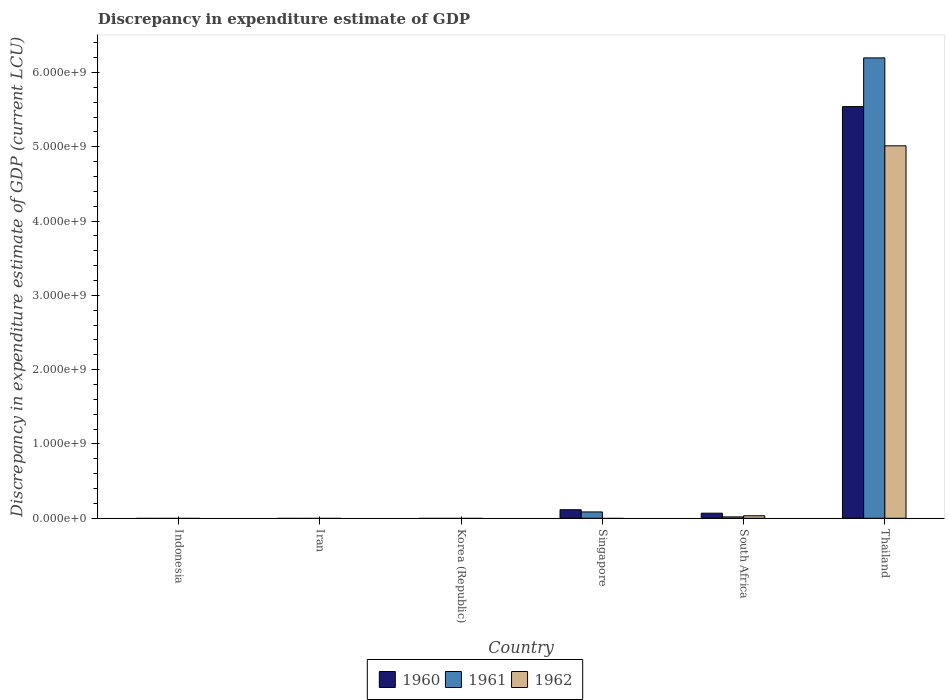How many bars are there on the 4th tick from the right?
Provide a short and direct response. 0. What is the label of the 5th group of bars from the left?
Offer a very short reply. South Africa. In how many cases, is the number of bars for a given country not equal to the number of legend labels?
Provide a succinct answer. 4. What is the discrepancy in expenditure estimate of GDP in 1961 in South Africa?
Make the answer very short. 1.84e+07. Across all countries, what is the maximum discrepancy in expenditure estimate of GDP in 1962?
Your response must be concise. 5.01e+09. Across all countries, what is the minimum discrepancy in expenditure estimate of GDP in 1962?
Make the answer very short. 0. In which country was the discrepancy in expenditure estimate of GDP in 1960 maximum?
Provide a succinct answer. Thailand. What is the total discrepancy in expenditure estimate of GDP in 1961 in the graph?
Provide a short and direct response. 6.30e+09. What is the difference between the discrepancy in expenditure estimate of GDP in 1961 in Singapore and that in South Africa?
Keep it short and to the point. 6.69e+07. What is the difference between the discrepancy in expenditure estimate of GDP in 1962 in Thailand and the discrepancy in expenditure estimate of GDP in 1961 in Indonesia?
Your response must be concise. 5.01e+09. What is the average discrepancy in expenditure estimate of GDP in 1961 per country?
Offer a terse response. 1.05e+09. What is the difference between the discrepancy in expenditure estimate of GDP of/in 1962 and discrepancy in expenditure estimate of GDP of/in 1960 in South Africa?
Your answer should be very brief. -3.43e+07. In how many countries, is the discrepancy in expenditure estimate of GDP in 1961 greater than 600000000 LCU?
Provide a short and direct response. 1. What is the ratio of the discrepancy in expenditure estimate of GDP in 1961 in Singapore to that in Thailand?
Ensure brevity in your answer.  0.01. What is the difference between the highest and the second highest discrepancy in expenditure estimate of GDP in 1960?
Your answer should be very brief. 4.66e+07. What is the difference between the highest and the lowest discrepancy in expenditure estimate of GDP in 1962?
Provide a short and direct response. 5.01e+09. Is the sum of the discrepancy in expenditure estimate of GDP in 1960 in South Africa and Thailand greater than the maximum discrepancy in expenditure estimate of GDP in 1962 across all countries?
Ensure brevity in your answer.  Yes. Is it the case that in every country, the sum of the discrepancy in expenditure estimate of GDP in 1962 and discrepancy in expenditure estimate of GDP in 1960 is greater than the discrepancy in expenditure estimate of GDP in 1961?
Provide a short and direct response. No. How many bars are there?
Your response must be concise. 8. How many countries are there in the graph?
Provide a short and direct response. 6. What is the difference between two consecutive major ticks on the Y-axis?
Your response must be concise. 1.00e+09. Where does the legend appear in the graph?
Provide a short and direct response. Bottom center. How are the legend labels stacked?
Make the answer very short. Horizontal. What is the title of the graph?
Make the answer very short. Discrepancy in expenditure estimate of GDP. Does "2006" appear as one of the legend labels in the graph?
Make the answer very short. No. What is the label or title of the Y-axis?
Ensure brevity in your answer.  Discrepancy in expenditure estimate of GDP (current LCU). What is the Discrepancy in expenditure estimate of GDP (current LCU) in 1960 in Indonesia?
Offer a terse response. 0. What is the Discrepancy in expenditure estimate of GDP (current LCU) of 1961 in Indonesia?
Your answer should be compact. 0. What is the Discrepancy in expenditure estimate of GDP (current LCU) of 1960 in Iran?
Give a very brief answer. 0. What is the Discrepancy in expenditure estimate of GDP (current LCU) in 1961 in Iran?
Give a very brief answer. 0. What is the Discrepancy in expenditure estimate of GDP (current LCU) in 1962 in Iran?
Your answer should be very brief. 0. What is the Discrepancy in expenditure estimate of GDP (current LCU) of 1961 in Korea (Republic)?
Provide a short and direct response. 0. What is the Discrepancy in expenditure estimate of GDP (current LCU) in 1960 in Singapore?
Your answer should be very brief. 1.15e+08. What is the Discrepancy in expenditure estimate of GDP (current LCU) in 1961 in Singapore?
Keep it short and to the point. 8.53e+07. What is the Discrepancy in expenditure estimate of GDP (current LCU) of 1960 in South Africa?
Keep it short and to the point. 6.83e+07. What is the Discrepancy in expenditure estimate of GDP (current LCU) in 1961 in South Africa?
Keep it short and to the point. 1.84e+07. What is the Discrepancy in expenditure estimate of GDP (current LCU) in 1962 in South Africa?
Offer a terse response. 3.40e+07. What is the Discrepancy in expenditure estimate of GDP (current LCU) in 1960 in Thailand?
Make the answer very short. 5.54e+09. What is the Discrepancy in expenditure estimate of GDP (current LCU) of 1961 in Thailand?
Your response must be concise. 6.20e+09. What is the Discrepancy in expenditure estimate of GDP (current LCU) in 1962 in Thailand?
Ensure brevity in your answer.  5.01e+09. Across all countries, what is the maximum Discrepancy in expenditure estimate of GDP (current LCU) of 1960?
Your response must be concise. 5.54e+09. Across all countries, what is the maximum Discrepancy in expenditure estimate of GDP (current LCU) of 1961?
Offer a terse response. 6.20e+09. Across all countries, what is the maximum Discrepancy in expenditure estimate of GDP (current LCU) of 1962?
Your answer should be compact. 5.01e+09. Across all countries, what is the minimum Discrepancy in expenditure estimate of GDP (current LCU) of 1960?
Offer a terse response. 0. Across all countries, what is the minimum Discrepancy in expenditure estimate of GDP (current LCU) of 1962?
Make the answer very short. 0. What is the total Discrepancy in expenditure estimate of GDP (current LCU) of 1960 in the graph?
Ensure brevity in your answer.  5.72e+09. What is the total Discrepancy in expenditure estimate of GDP (current LCU) in 1961 in the graph?
Ensure brevity in your answer.  6.30e+09. What is the total Discrepancy in expenditure estimate of GDP (current LCU) of 1962 in the graph?
Offer a terse response. 5.05e+09. What is the difference between the Discrepancy in expenditure estimate of GDP (current LCU) of 1960 in Singapore and that in South Africa?
Your response must be concise. 4.66e+07. What is the difference between the Discrepancy in expenditure estimate of GDP (current LCU) in 1961 in Singapore and that in South Africa?
Provide a short and direct response. 6.69e+07. What is the difference between the Discrepancy in expenditure estimate of GDP (current LCU) in 1960 in Singapore and that in Thailand?
Give a very brief answer. -5.43e+09. What is the difference between the Discrepancy in expenditure estimate of GDP (current LCU) of 1961 in Singapore and that in Thailand?
Make the answer very short. -6.11e+09. What is the difference between the Discrepancy in expenditure estimate of GDP (current LCU) in 1960 in South Africa and that in Thailand?
Your answer should be compact. -5.47e+09. What is the difference between the Discrepancy in expenditure estimate of GDP (current LCU) of 1961 in South Africa and that in Thailand?
Your answer should be very brief. -6.18e+09. What is the difference between the Discrepancy in expenditure estimate of GDP (current LCU) of 1962 in South Africa and that in Thailand?
Give a very brief answer. -4.98e+09. What is the difference between the Discrepancy in expenditure estimate of GDP (current LCU) in 1960 in Singapore and the Discrepancy in expenditure estimate of GDP (current LCU) in 1961 in South Africa?
Keep it short and to the point. 9.65e+07. What is the difference between the Discrepancy in expenditure estimate of GDP (current LCU) in 1960 in Singapore and the Discrepancy in expenditure estimate of GDP (current LCU) in 1962 in South Africa?
Provide a short and direct response. 8.09e+07. What is the difference between the Discrepancy in expenditure estimate of GDP (current LCU) in 1961 in Singapore and the Discrepancy in expenditure estimate of GDP (current LCU) in 1962 in South Africa?
Ensure brevity in your answer.  5.13e+07. What is the difference between the Discrepancy in expenditure estimate of GDP (current LCU) of 1960 in Singapore and the Discrepancy in expenditure estimate of GDP (current LCU) of 1961 in Thailand?
Your response must be concise. -6.08e+09. What is the difference between the Discrepancy in expenditure estimate of GDP (current LCU) in 1960 in Singapore and the Discrepancy in expenditure estimate of GDP (current LCU) in 1962 in Thailand?
Give a very brief answer. -4.90e+09. What is the difference between the Discrepancy in expenditure estimate of GDP (current LCU) in 1961 in Singapore and the Discrepancy in expenditure estimate of GDP (current LCU) in 1962 in Thailand?
Your answer should be compact. -4.93e+09. What is the difference between the Discrepancy in expenditure estimate of GDP (current LCU) of 1960 in South Africa and the Discrepancy in expenditure estimate of GDP (current LCU) of 1961 in Thailand?
Make the answer very short. -6.13e+09. What is the difference between the Discrepancy in expenditure estimate of GDP (current LCU) in 1960 in South Africa and the Discrepancy in expenditure estimate of GDP (current LCU) in 1962 in Thailand?
Keep it short and to the point. -4.95e+09. What is the difference between the Discrepancy in expenditure estimate of GDP (current LCU) of 1961 in South Africa and the Discrepancy in expenditure estimate of GDP (current LCU) of 1962 in Thailand?
Your answer should be compact. -5.00e+09. What is the average Discrepancy in expenditure estimate of GDP (current LCU) in 1960 per country?
Your answer should be very brief. 9.54e+08. What is the average Discrepancy in expenditure estimate of GDP (current LCU) in 1961 per country?
Your answer should be compact. 1.05e+09. What is the average Discrepancy in expenditure estimate of GDP (current LCU) in 1962 per country?
Your answer should be compact. 8.41e+08. What is the difference between the Discrepancy in expenditure estimate of GDP (current LCU) of 1960 and Discrepancy in expenditure estimate of GDP (current LCU) of 1961 in Singapore?
Give a very brief answer. 2.96e+07. What is the difference between the Discrepancy in expenditure estimate of GDP (current LCU) of 1960 and Discrepancy in expenditure estimate of GDP (current LCU) of 1961 in South Africa?
Provide a succinct answer. 4.99e+07. What is the difference between the Discrepancy in expenditure estimate of GDP (current LCU) in 1960 and Discrepancy in expenditure estimate of GDP (current LCU) in 1962 in South Africa?
Keep it short and to the point. 3.43e+07. What is the difference between the Discrepancy in expenditure estimate of GDP (current LCU) in 1961 and Discrepancy in expenditure estimate of GDP (current LCU) in 1962 in South Africa?
Keep it short and to the point. -1.56e+07. What is the difference between the Discrepancy in expenditure estimate of GDP (current LCU) in 1960 and Discrepancy in expenditure estimate of GDP (current LCU) in 1961 in Thailand?
Your response must be concise. -6.56e+08. What is the difference between the Discrepancy in expenditure estimate of GDP (current LCU) of 1960 and Discrepancy in expenditure estimate of GDP (current LCU) of 1962 in Thailand?
Keep it short and to the point. 5.28e+08. What is the difference between the Discrepancy in expenditure estimate of GDP (current LCU) in 1961 and Discrepancy in expenditure estimate of GDP (current LCU) in 1962 in Thailand?
Offer a very short reply. 1.18e+09. What is the ratio of the Discrepancy in expenditure estimate of GDP (current LCU) of 1960 in Singapore to that in South Africa?
Keep it short and to the point. 1.68. What is the ratio of the Discrepancy in expenditure estimate of GDP (current LCU) in 1961 in Singapore to that in South Africa?
Offer a very short reply. 4.64. What is the ratio of the Discrepancy in expenditure estimate of GDP (current LCU) in 1960 in Singapore to that in Thailand?
Provide a short and direct response. 0.02. What is the ratio of the Discrepancy in expenditure estimate of GDP (current LCU) of 1961 in Singapore to that in Thailand?
Ensure brevity in your answer.  0.01. What is the ratio of the Discrepancy in expenditure estimate of GDP (current LCU) of 1960 in South Africa to that in Thailand?
Provide a short and direct response. 0.01. What is the ratio of the Discrepancy in expenditure estimate of GDP (current LCU) in 1961 in South Africa to that in Thailand?
Your answer should be very brief. 0. What is the ratio of the Discrepancy in expenditure estimate of GDP (current LCU) of 1962 in South Africa to that in Thailand?
Provide a short and direct response. 0.01. What is the difference between the highest and the second highest Discrepancy in expenditure estimate of GDP (current LCU) of 1960?
Provide a succinct answer. 5.43e+09. What is the difference between the highest and the second highest Discrepancy in expenditure estimate of GDP (current LCU) of 1961?
Give a very brief answer. 6.11e+09. What is the difference between the highest and the lowest Discrepancy in expenditure estimate of GDP (current LCU) in 1960?
Provide a short and direct response. 5.54e+09. What is the difference between the highest and the lowest Discrepancy in expenditure estimate of GDP (current LCU) in 1961?
Offer a very short reply. 6.20e+09. What is the difference between the highest and the lowest Discrepancy in expenditure estimate of GDP (current LCU) in 1962?
Your answer should be very brief. 5.01e+09. 